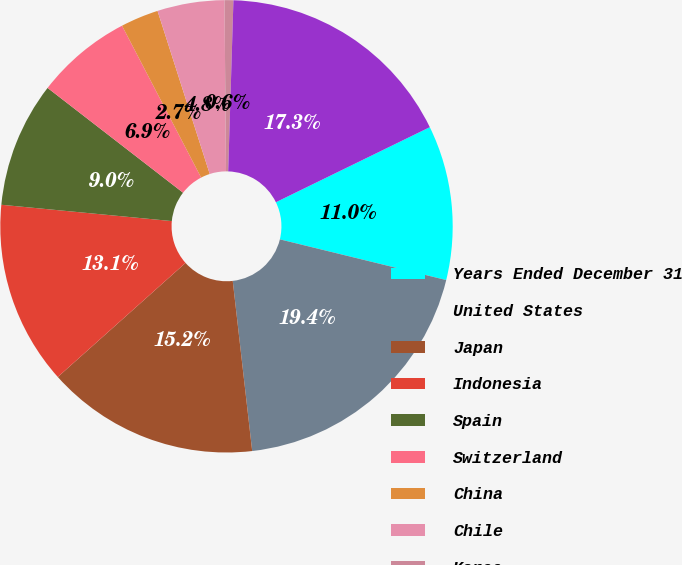<chart> <loc_0><loc_0><loc_500><loc_500><pie_chart><fcel>Years Ended December 31<fcel>United States<fcel>Japan<fcel>Indonesia<fcel>Spain<fcel>Switzerland<fcel>China<fcel>Chile<fcel>Korea<fcel>Other<nl><fcel>11.04%<fcel>19.37%<fcel>15.21%<fcel>13.12%<fcel>8.96%<fcel>6.88%<fcel>2.71%<fcel>4.79%<fcel>0.63%<fcel>17.29%<nl></chart> 